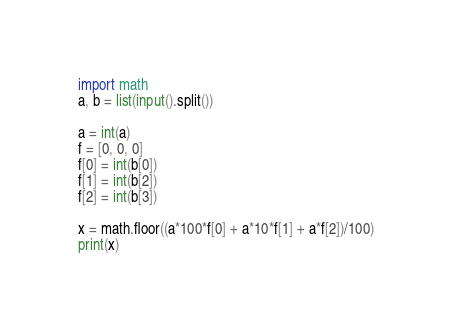<code> <loc_0><loc_0><loc_500><loc_500><_Python_>import math
a, b = list(input().split())
 
a = int(a)
f = [0, 0, 0]
f[0] = int(b[0])
f[1] = int(b[2])
f[2] = int(b[3])
 
x = math.floor((a*100*f[0] + a*10*f[1] + a*f[2])/100)
print(x)</code> 